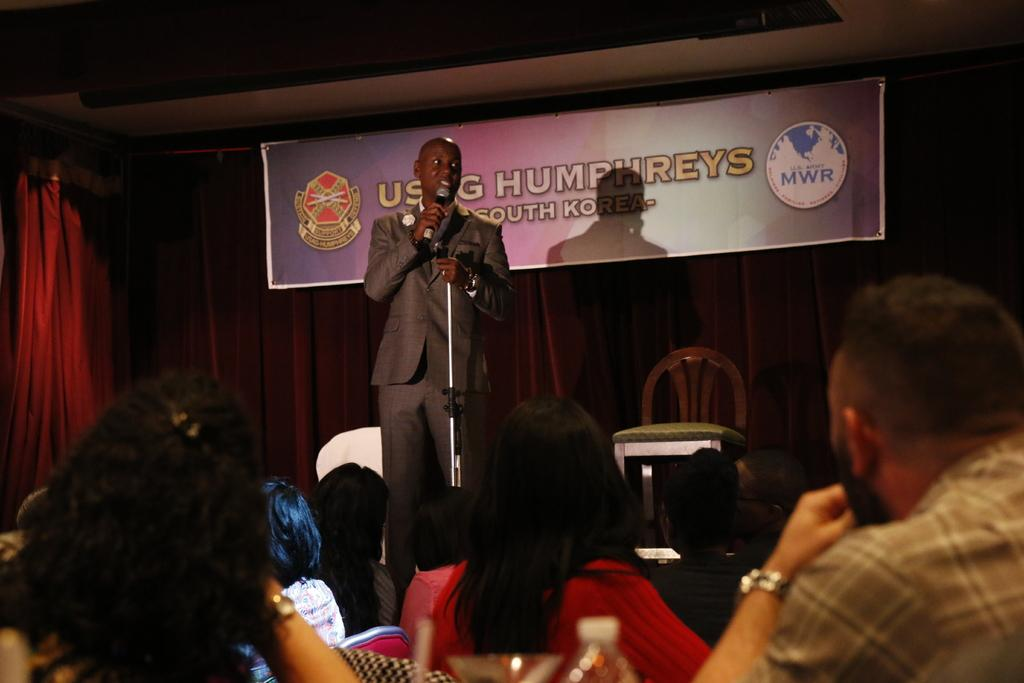Who is the main subject in the image? There is a person in the image. What is the person holding in the image? The person is holding a microphone. Where is the person located in the image? The person is on a stage. What can be found on the stage besides the person? The stage contains a chair and a poster. Can you describe the poster on the stage? The poster has text and a logo on it. Who might be listening to the person in the image? There is an audience in front of the person. What type of plants can be seen growing on the stage in the image? There are no plants visible on the stage in the image. 